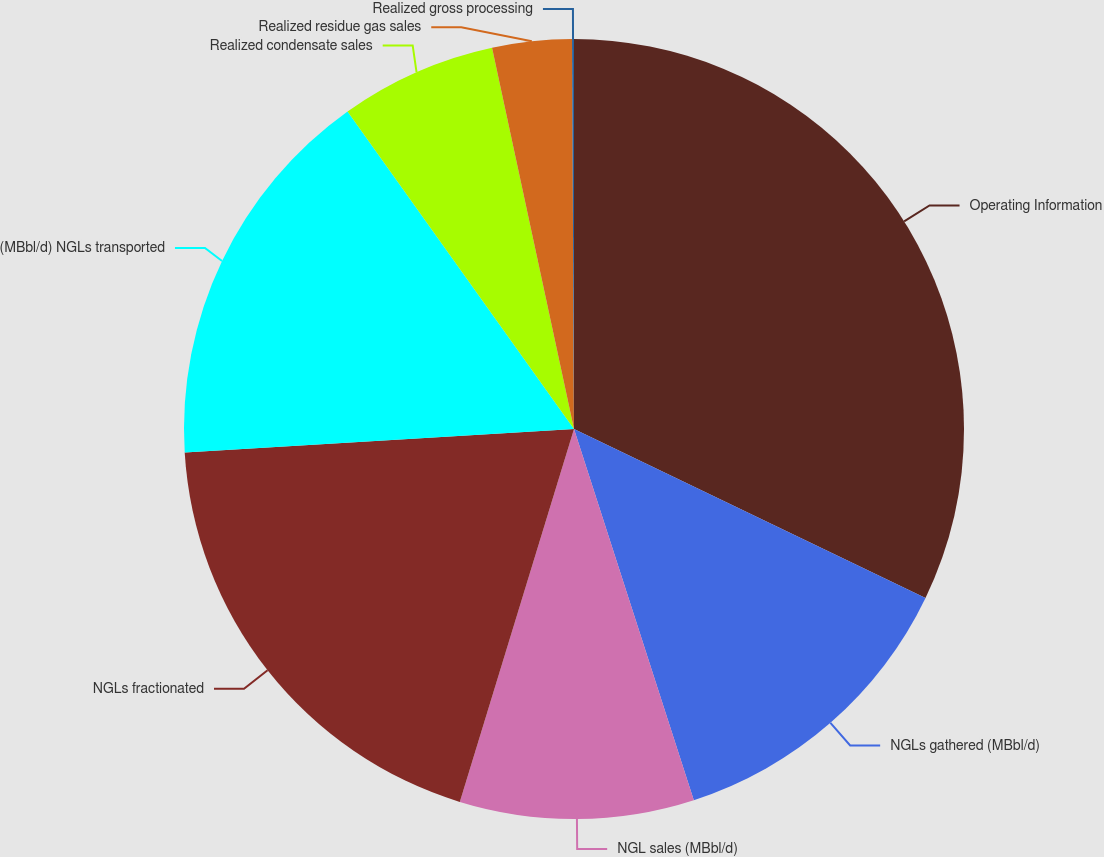<chart> <loc_0><loc_0><loc_500><loc_500><pie_chart><fcel>Operating Information<fcel>NGLs gathered (MBbl/d)<fcel>NGL sales (MBbl/d)<fcel>NGLs fractionated<fcel>(MBbl/d) NGLs transported<fcel>Realized condensate sales<fcel>Realized residue gas sales<fcel>Realized gross processing<nl><fcel>32.13%<fcel>12.9%<fcel>9.7%<fcel>19.31%<fcel>16.1%<fcel>6.49%<fcel>3.29%<fcel>0.08%<nl></chart> 